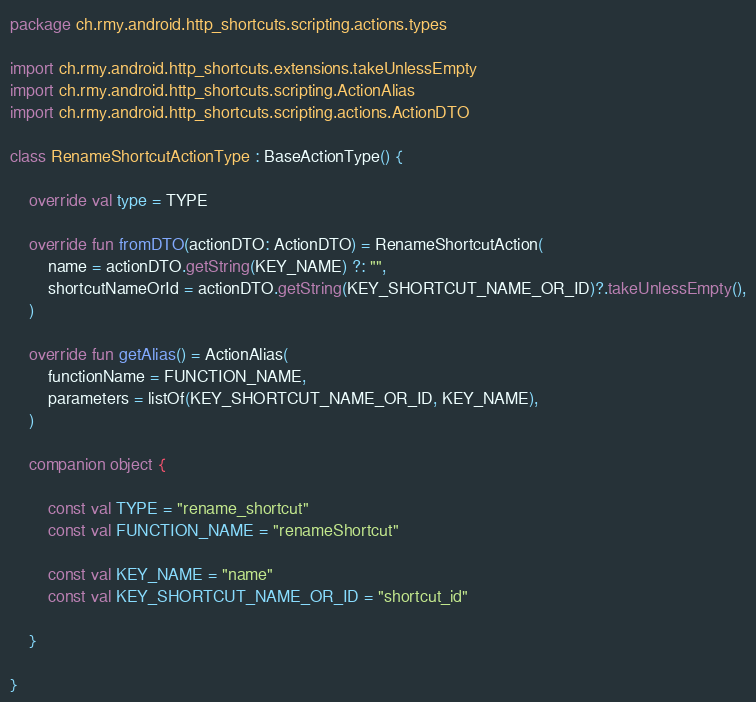Convert code to text. <code><loc_0><loc_0><loc_500><loc_500><_Kotlin_>package ch.rmy.android.http_shortcuts.scripting.actions.types

import ch.rmy.android.http_shortcuts.extensions.takeUnlessEmpty
import ch.rmy.android.http_shortcuts.scripting.ActionAlias
import ch.rmy.android.http_shortcuts.scripting.actions.ActionDTO

class RenameShortcutActionType : BaseActionType() {

    override val type = TYPE

    override fun fromDTO(actionDTO: ActionDTO) = RenameShortcutAction(
        name = actionDTO.getString(KEY_NAME) ?: "",
        shortcutNameOrId = actionDTO.getString(KEY_SHORTCUT_NAME_OR_ID)?.takeUnlessEmpty(),
    )

    override fun getAlias() = ActionAlias(
        functionName = FUNCTION_NAME,
        parameters = listOf(KEY_SHORTCUT_NAME_OR_ID, KEY_NAME),
    )

    companion object {

        const val TYPE = "rename_shortcut"
        const val FUNCTION_NAME = "renameShortcut"

        const val KEY_NAME = "name"
        const val KEY_SHORTCUT_NAME_OR_ID = "shortcut_id"

    }

}</code> 